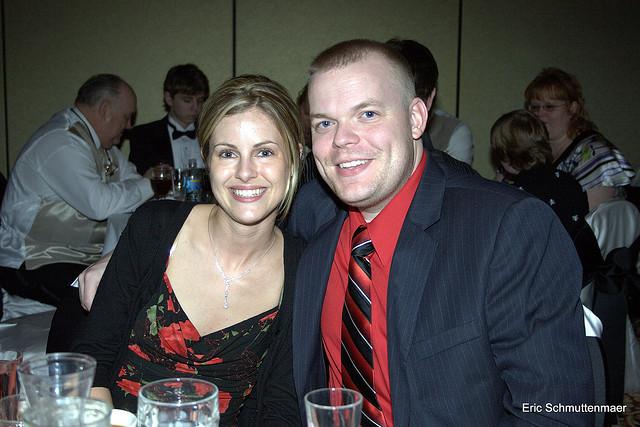How many people are wearing black tops?
Give a very brief answer. 3. Do they appear to be at a party?
Short answer required. Yes. Is this a traditional location for a wedding reception?
Short answer required. Yes. What color shirt is the guy wearing?
Answer briefly. Red. Are they happy?
Short answer required. Yes. How many glasses are set?
Write a very short answer. 4. Is the lady surprised?
Keep it brief. No. Is the woman smiling?
Keep it brief. Yes. How many glasses of wine has he had?
Answer briefly. 1. What kind of event is this man most likely attending?
Give a very brief answer. Wedding. What type of glass is the woman holding?
Give a very brief answer. Wine. Does the man appear irritated?
Give a very brief answer. No. Is the man staring at something?
Be succinct. Yes. Is the man trying to solve a computer problem?
Keep it brief. No. Do they match?
Quick response, please. Yes. 